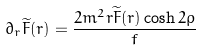<formula> <loc_0><loc_0><loc_500><loc_500>\partial _ { r } \widetilde { F } ( r ) = \frac { 2 m ^ { 2 } r \widetilde { F } ( r ) \cosh 2 \rho } { f }</formula> 